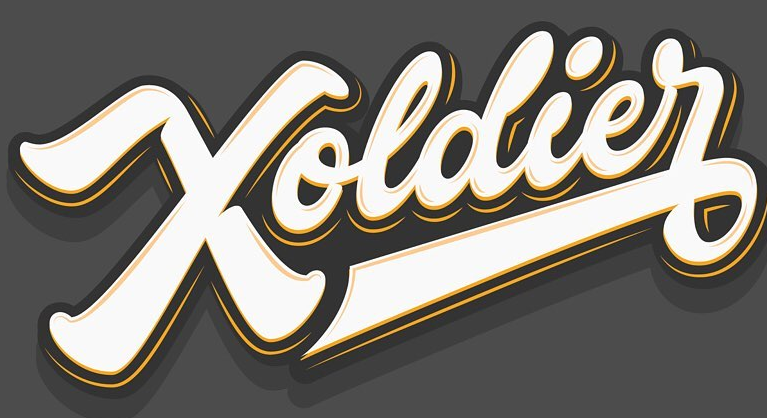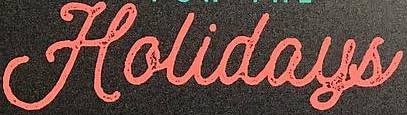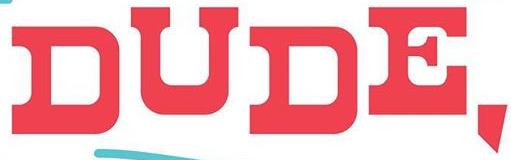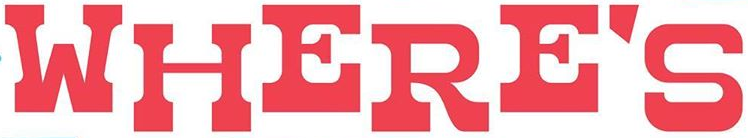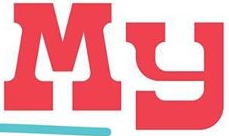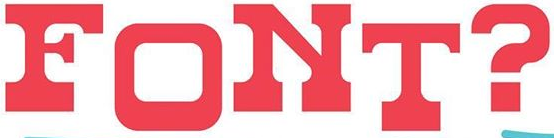Transcribe the words shown in these images in order, separated by a semicolon. Xoldier; Holidays; DUDE,; WHERE'S; My; FONT? 